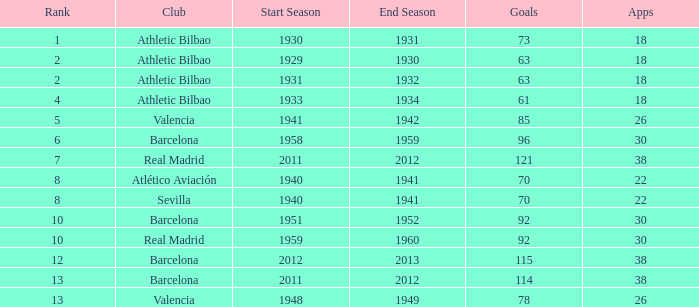What are the apps for less than 61 goals and before rank 6? None. 